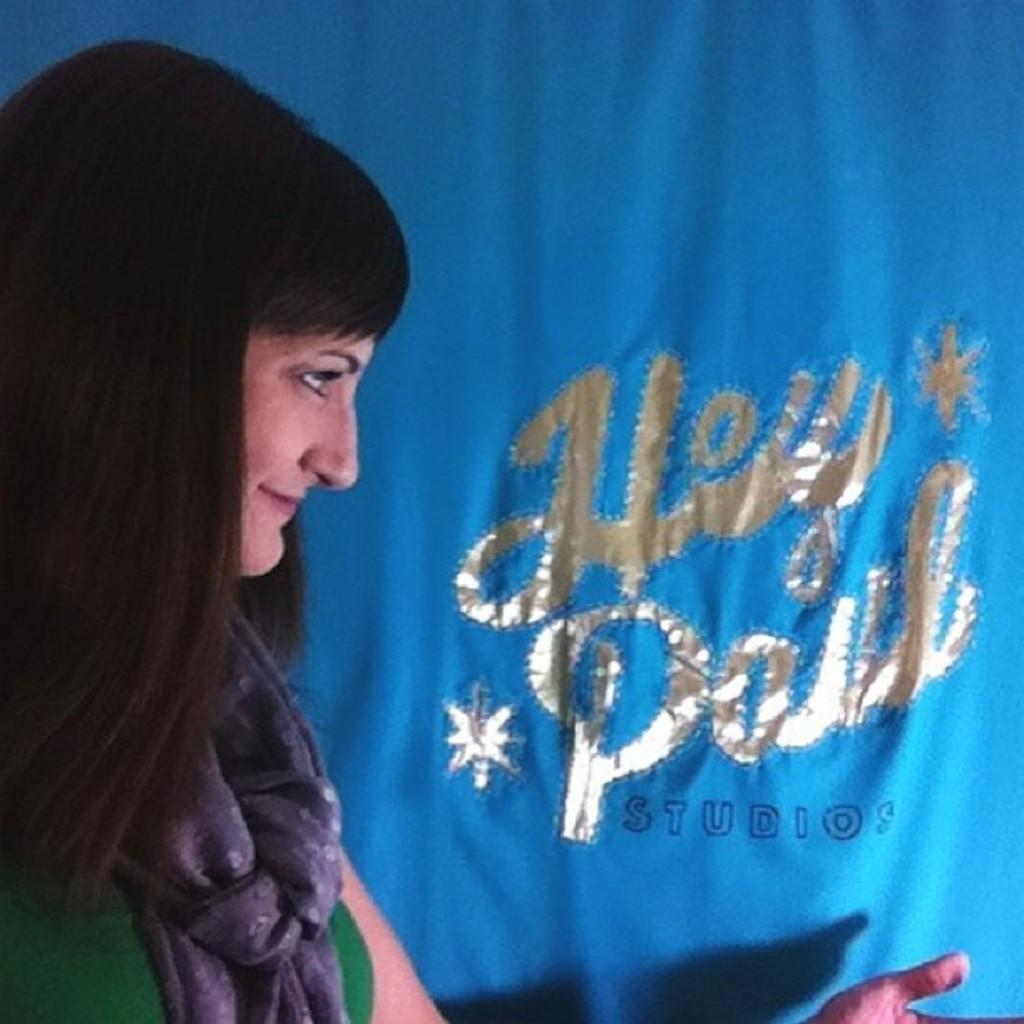Who is the main subject in the image? There is a woman in the image. What is the woman wearing in the image? The woman is wearing a scarf in the image. What is the woman doing in the image? The woman is looking at text in the image. What is the medium on which the text is written? The text is written on a cloth in the image. How many eggs are visible on the woman's toes in the image? There are no eggs or toes visible in the image. 